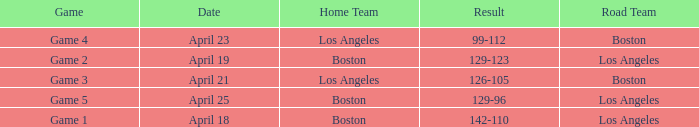WHAT IS THE HOME TEAM, RESULT 99-112? Los Angeles. 